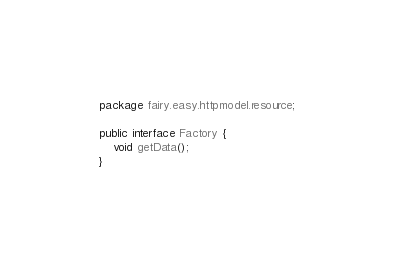<code> <loc_0><loc_0><loc_500><loc_500><_Java_>package fairy.easy.httpmodel.resource;

public interface Factory {
    void getData();
}
</code> 